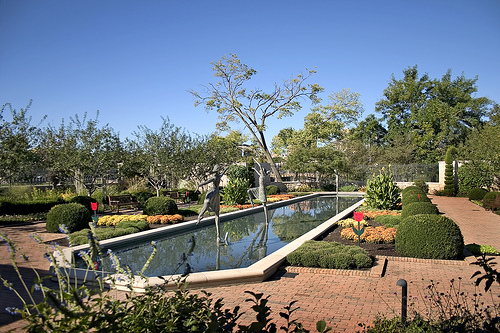<image>
Can you confirm if the sky is behind the trees? Yes. From this viewpoint, the sky is positioned behind the trees, with the trees partially or fully occluding the sky. Where is the bush in relation to the patio? Is it behind the patio? No. The bush is not behind the patio. From this viewpoint, the bush appears to be positioned elsewhere in the scene. Where is the pool in relation to the ground? Is it under the ground? Yes. The pool is positioned underneath the ground, with the ground above it in the vertical space. 